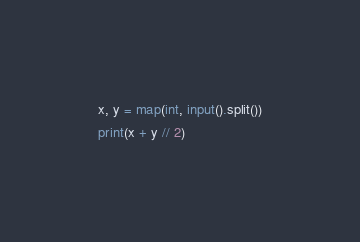Convert code to text. <code><loc_0><loc_0><loc_500><loc_500><_Python_>x, y = map(int, input().split())
print(x + y // 2)
</code> 